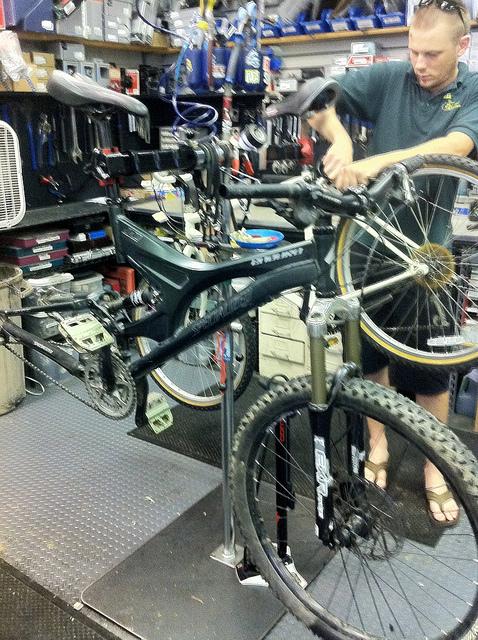Is the man riding the bike?
Keep it brief. No. What kind of event is taking place?
Answer briefly. Fixing bike. Is this a garage?
Be succinct. Yes. Does this man have long hair?
Keep it brief. No. 